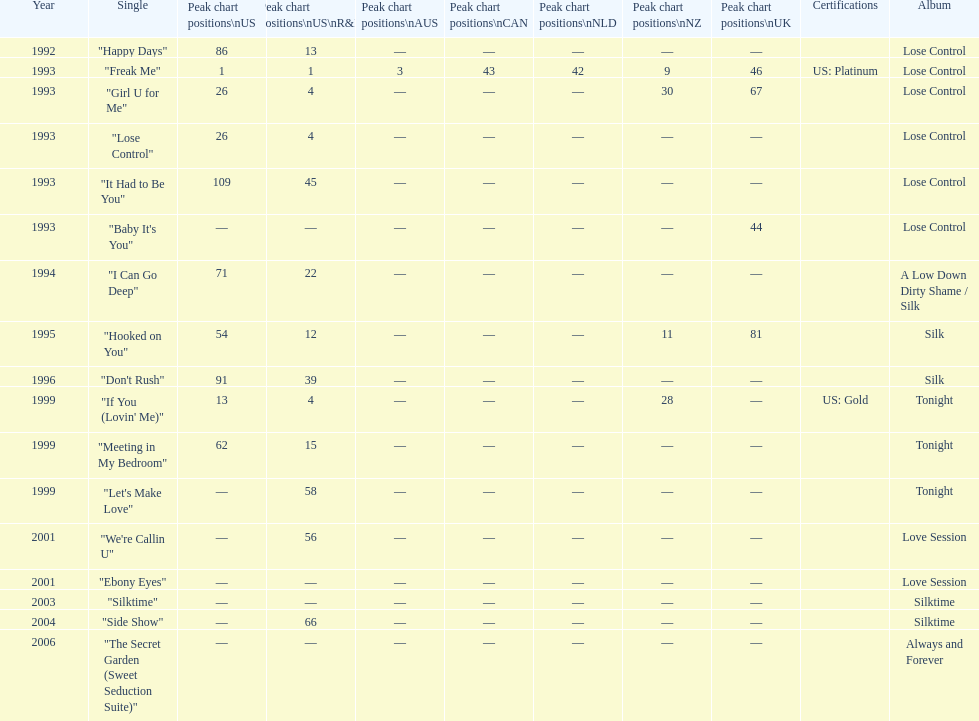Which single is the most in terms of how many times it charted? "Freak Me". 